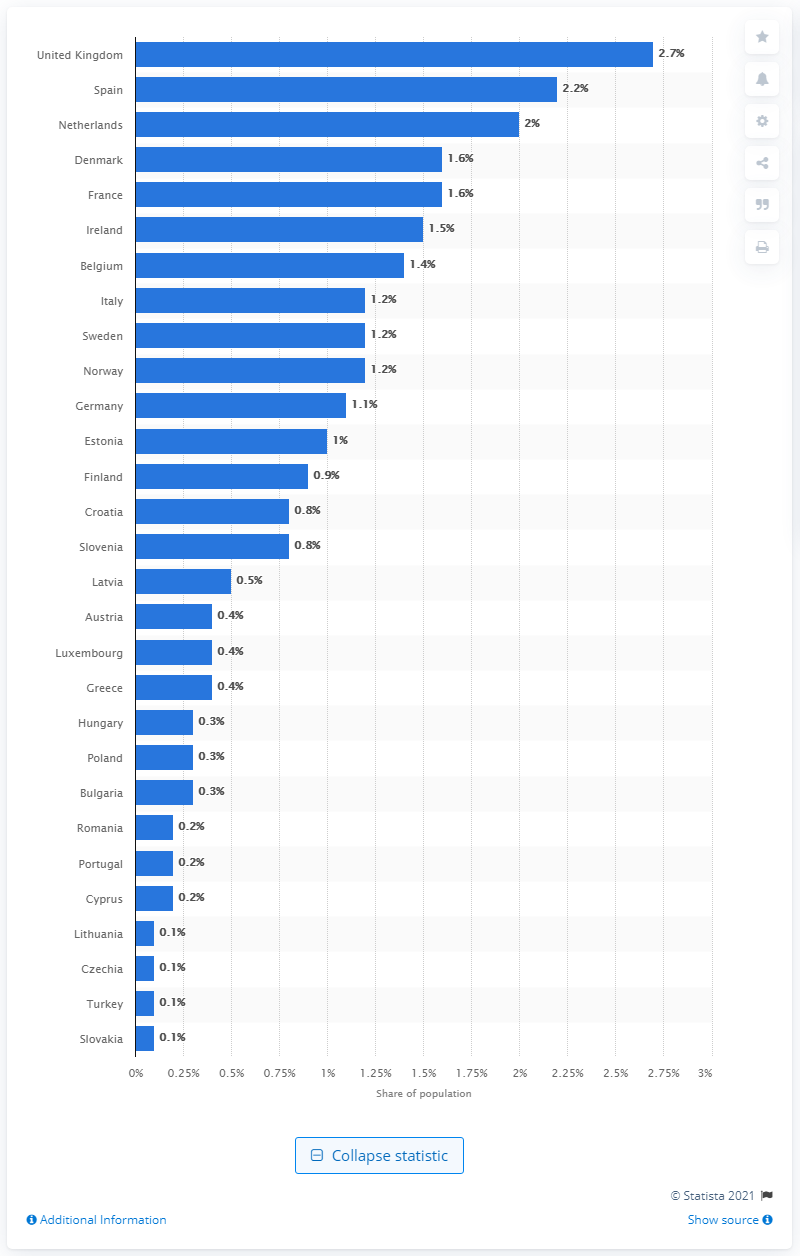Specify some key components in this picture. In 2019, the percentage of people in Spain and the Netherlands who used cocaine was 2.2%. A recent study has revealed that approximately 2.7% of the population in the UK used cocaine in the previous year. 